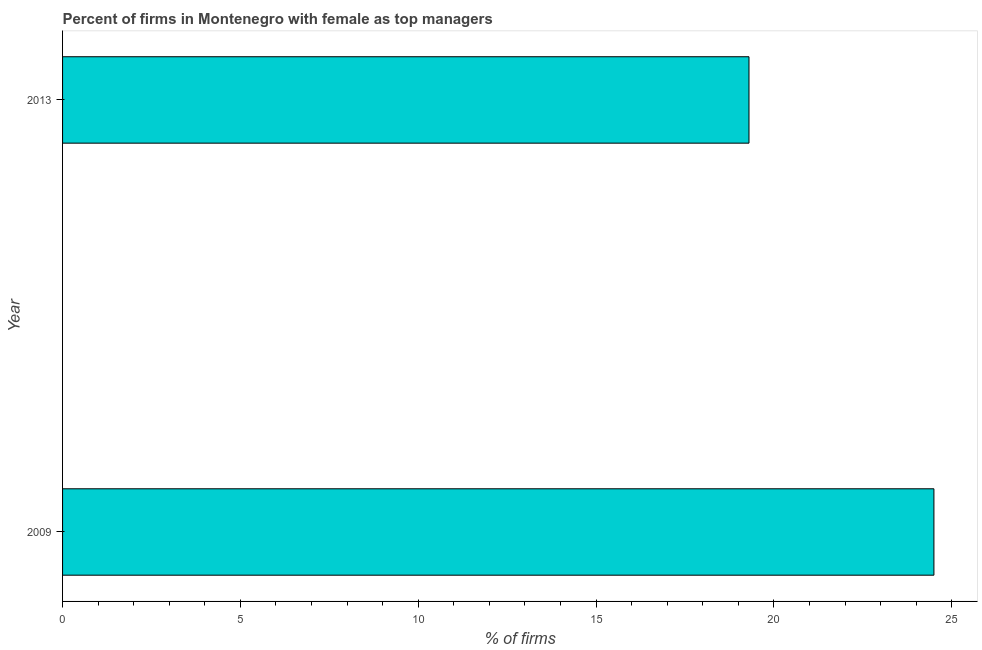Does the graph contain any zero values?
Provide a succinct answer. No. Does the graph contain grids?
Offer a terse response. No. What is the title of the graph?
Your answer should be compact. Percent of firms in Montenegro with female as top managers. What is the label or title of the X-axis?
Offer a terse response. % of firms. What is the label or title of the Y-axis?
Your answer should be compact. Year. What is the percentage of firms with female as top manager in 2013?
Provide a succinct answer. 19.3. Across all years, what is the maximum percentage of firms with female as top manager?
Your response must be concise. 24.5. Across all years, what is the minimum percentage of firms with female as top manager?
Offer a very short reply. 19.3. In which year was the percentage of firms with female as top manager minimum?
Give a very brief answer. 2013. What is the sum of the percentage of firms with female as top manager?
Give a very brief answer. 43.8. What is the difference between the percentage of firms with female as top manager in 2009 and 2013?
Make the answer very short. 5.2. What is the average percentage of firms with female as top manager per year?
Give a very brief answer. 21.9. What is the median percentage of firms with female as top manager?
Offer a terse response. 21.9. In how many years, is the percentage of firms with female as top manager greater than 18 %?
Your answer should be very brief. 2. Do a majority of the years between 2009 and 2013 (inclusive) have percentage of firms with female as top manager greater than 20 %?
Provide a succinct answer. No. What is the ratio of the percentage of firms with female as top manager in 2009 to that in 2013?
Ensure brevity in your answer.  1.27. Is the percentage of firms with female as top manager in 2009 less than that in 2013?
Your response must be concise. No. In how many years, is the percentage of firms with female as top manager greater than the average percentage of firms with female as top manager taken over all years?
Offer a very short reply. 1. How many bars are there?
Keep it short and to the point. 2. Are all the bars in the graph horizontal?
Your answer should be very brief. Yes. How many years are there in the graph?
Your answer should be compact. 2. What is the difference between two consecutive major ticks on the X-axis?
Provide a short and direct response. 5. What is the % of firms in 2013?
Make the answer very short. 19.3. What is the ratio of the % of firms in 2009 to that in 2013?
Provide a succinct answer. 1.27. 